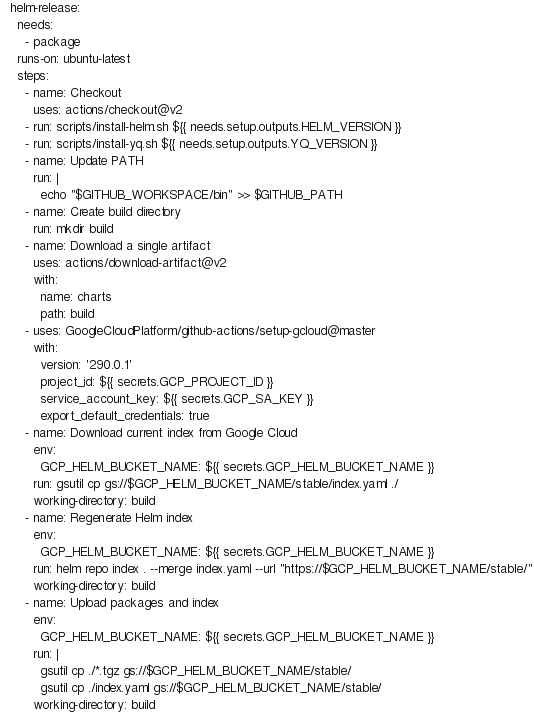Convert code to text. <code><loc_0><loc_0><loc_500><loc_500><_YAML_>  helm-release:
    needs:
      - package
    runs-on: ubuntu-latest
    steps:
      - name: Checkout
        uses: actions/checkout@v2
      - run: scripts/install-helm.sh ${{ needs.setup.outputs.HELM_VERSION }}
      - run: scripts/install-yq.sh ${{ needs.setup.outputs.YQ_VERSION }}
      - name: Update PATH
        run: |
          echo "$GITHUB_WORKSPACE/bin" >> $GITHUB_PATH
      - name: Create build directory
        run: mkdir build
      - name: Download a single artifact
        uses: actions/download-artifact@v2
        with:
          name: charts
          path: build
      - uses: GoogleCloudPlatform/github-actions/setup-gcloud@master
        with:
          version: '290.0.1'
          project_id: ${{ secrets.GCP_PROJECT_ID }}
          service_account_key: ${{ secrets.GCP_SA_KEY }}
          export_default_credentials: true
      - name: Download current index from Google Cloud
        env:
          GCP_HELM_BUCKET_NAME: ${{ secrets.GCP_HELM_BUCKET_NAME }}
        run: gsutil cp gs://$GCP_HELM_BUCKET_NAME/stable/index.yaml ./
        working-directory: build
      - name: Regenerate Helm index
        env:
          GCP_HELM_BUCKET_NAME: ${{ secrets.GCP_HELM_BUCKET_NAME }}
        run: helm repo index . --merge index.yaml --url "https://$GCP_HELM_BUCKET_NAME/stable/"
        working-directory: build
      - name: Upload packages and index
        env:
          GCP_HELM_BUCKET_NAME: ${{ secrets.GCP_HELM_BUCKET_NAME }}
        run: |
          gsutil cp ./*.tgz gs://$GCP_HELM_BUCKET_NAME/stable/
          gsutil cp ./index.yaml gs://$GCP_HELM_BUCKET_NAME/stable/
        working-directory: build
</code> 